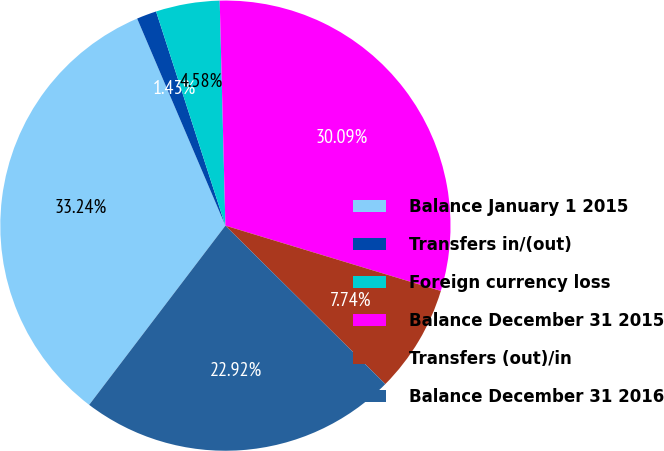Convert chart. <chart><loc_0><loc_0><loc_500><loc_500><pie_chart><fcel>Balance January 1 2015<fcel>Transfers in/(out)<fcel>Foreign currency loss<fcel>Balance December 31 2015<fcel>Transfers (out)/in<fcel>Balance December 31 2016<nl><fcel>33.24%<fcel>1.43%<fcel>4.58%<fcel>30.09%<fcel>7.74%<fcel>22.92%<nl></chart> 